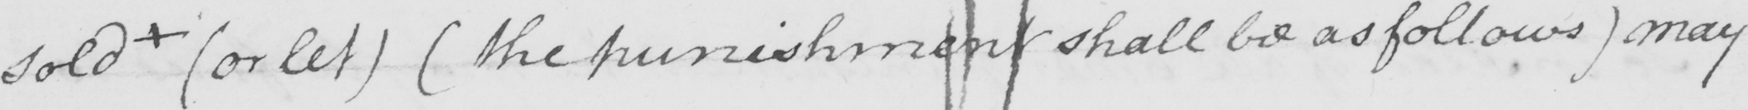Can you tell me what this handwritten text says? sold  +   ( or let )   ( the punishment shall be as follows )  may 